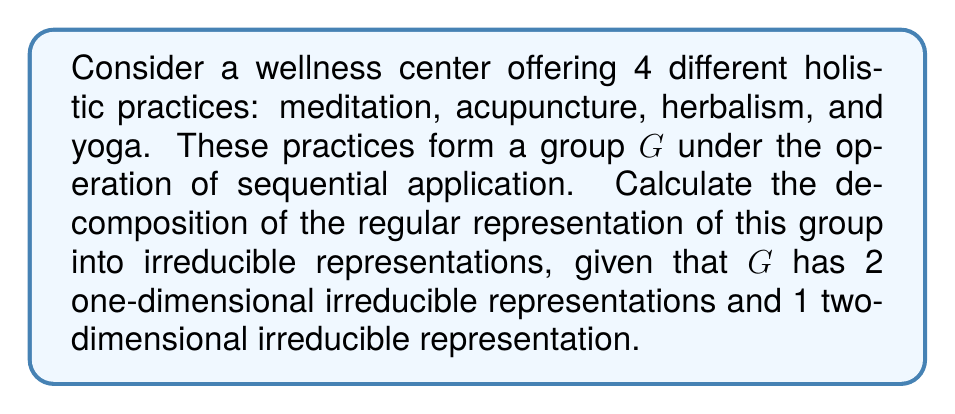Show me your answer to this math problem. Let's approach this step-by-step:

1) First, recall that for any finite group $G$, the regular representation decomposes as:

   $$\rho_{reg} = \bigoplus_i n_i \rho_i$$

   where $n_i$ is the dimension of the irreducible representation $\rho_i$.

2) We're given that $G$ has:
   - 2 one-dimensional irreducible representations (let's call them $\rho_1$ and $\rho_2$)
   - 1 two-dimensional irreducible representation (let's call it $\rho_3$)

3) The order of the group $|G|$ is 4, as there are 4 practices.

4) For a finite group, the dimension of the regular representation is equal to the order of the group. So:

   $$\dim(\rho_{reg}) = |G| = 4$$

5) Now, we can set up an equation based on the decomposition formula:

   $$4 = n_1 \cdot 1 + n_2 \cdot 1 + n_3 \cdot 2$$

   where $n_1$, $n_2$, and $n_3$ are the number of times each irreducible representation appears in the decomposition.

6) We also know that for the regular representation, each irreducible representation appears a number of times equal to its dimension. So:

   $n_1 = 1$
   $n_2 = 1$
   $n_3 = 2$

7) We can verify this satisfies our equation:

   $$4 = 1 \cdot 1 + 1 \cdot 1 + 2 \cdot 2$$

Therefore, the decomposition of the regular representation is:

$$\rho_{reg} = \rho_1 \oplus \rho_2 \oplus 2\rho_3$$
Answer: $\rho_{reg} = \rho_1 \oplus \rho_2 \oplus 2\rho_3$ 